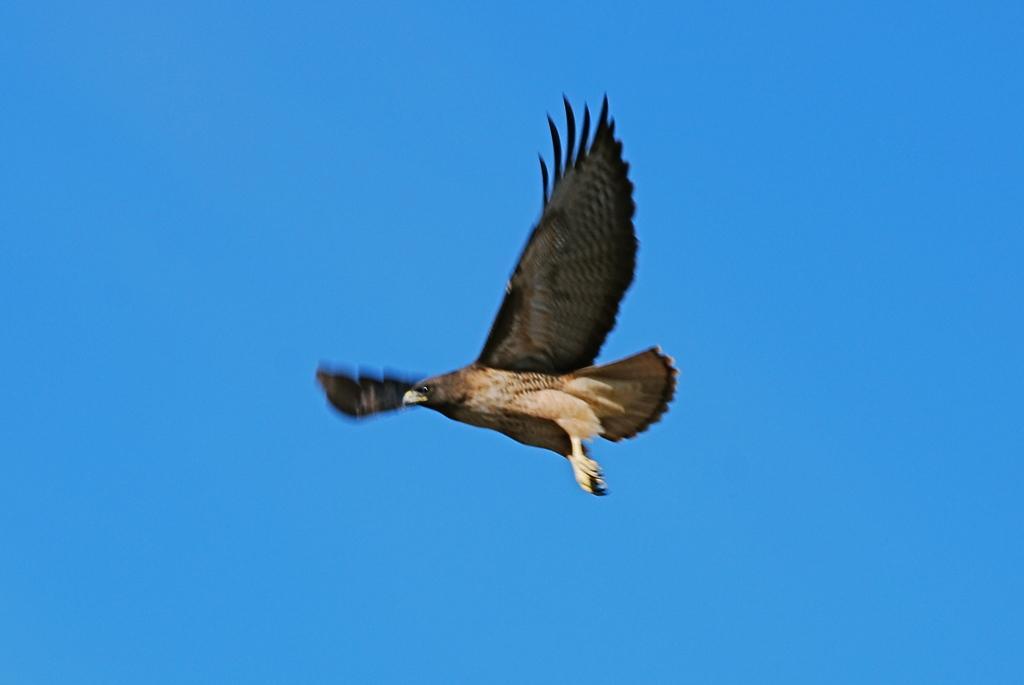Can you describe this image briefly? There is a bird in the blue color sky. 